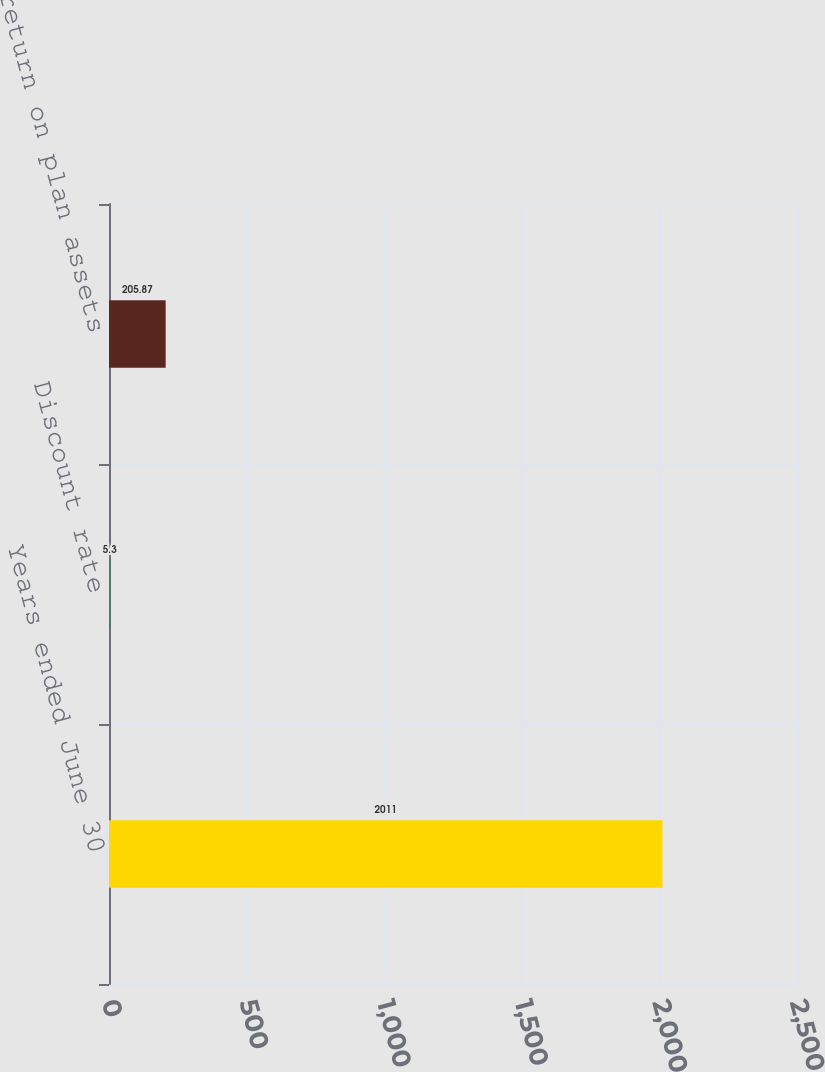Convert chart to OTSL. <chart><loc_0><loc_0><loc_500><loc_500><bar_chart><fcel>Years ended June 30<fcel>Discount rate<fcel>Expected return on plan assets<nl><fcel>2011<fcel>5.3<fcel>205.87<nl></chart> 